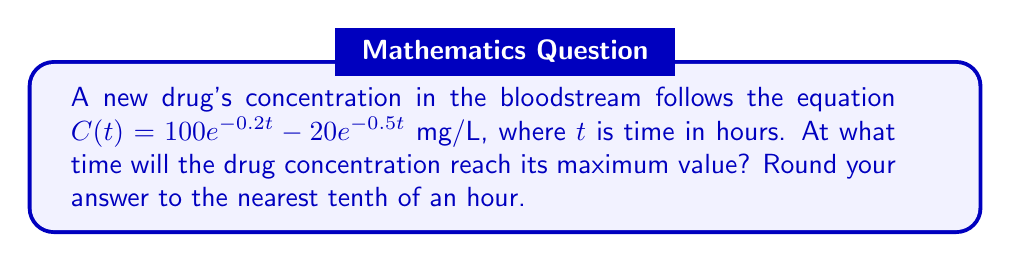Show me your answer to this math problem. To find the maximum concentration, we need to find the time $t$ when the derivative of $C(t)$ equals zero.

1) First, let's calculate the derivative of $C(t)$:
   $$\frac{dC}{dt} = -20e^{-0.2t} + 10e^{-0.5t}$$

2) Set the derivative equal to zero:
   $$-20e^{-0.2t} + 10e^{-0.5t} = 0$$

3) Rearrange the equation:
   $$20e^{-0.2t} = 10e^{-0.5t}$$

4) Divide both sides by 10:
   $$2e^{-0.2t} = e^{-0.5t}$$

5) Take the natural log of both sides:
   $$\ln(2) - 0.2t = -0.5t$$

6) Solve for $t$:
   $$\ln(2) = -0.5t + 0.2t = -0.3t$$
   $$t = \frac{\ln(2)}{0.3} \approx 2.31$$

7) Rounding to the nearest tenth:
   $$t \approx 2.3$$
Answer: 2.3 hours 